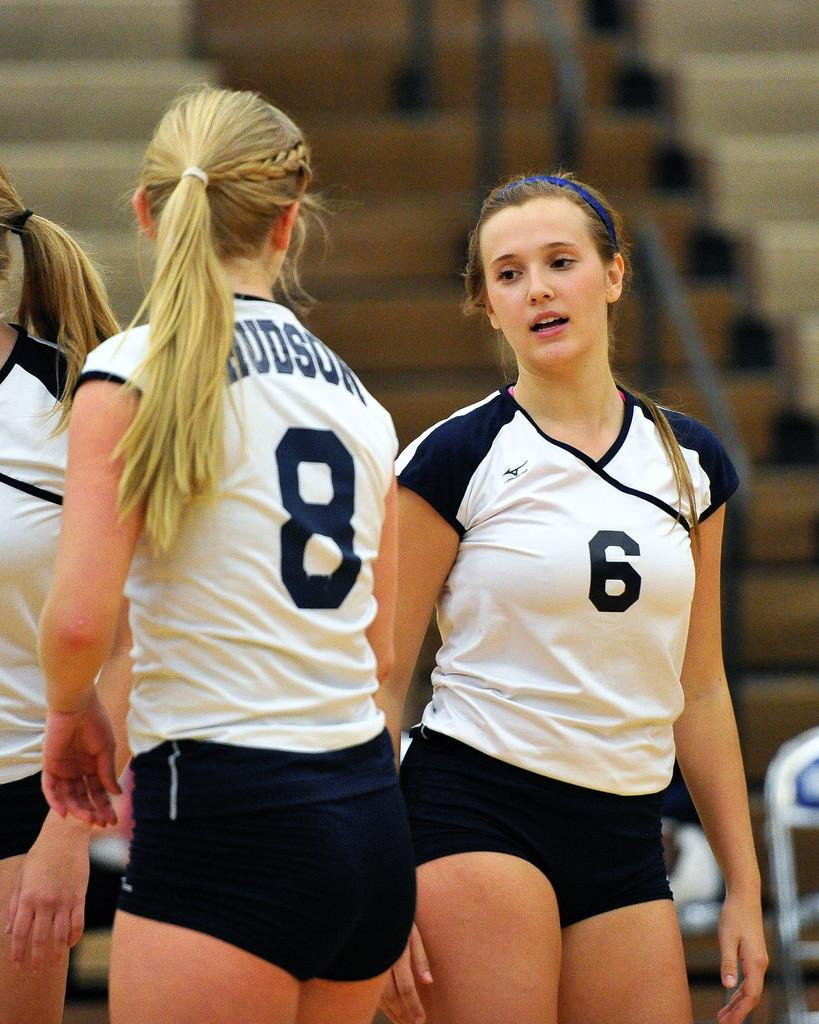<image>
Give a short and clear explanation of the subsequent image. tow girls on a team are numbers six and eight 